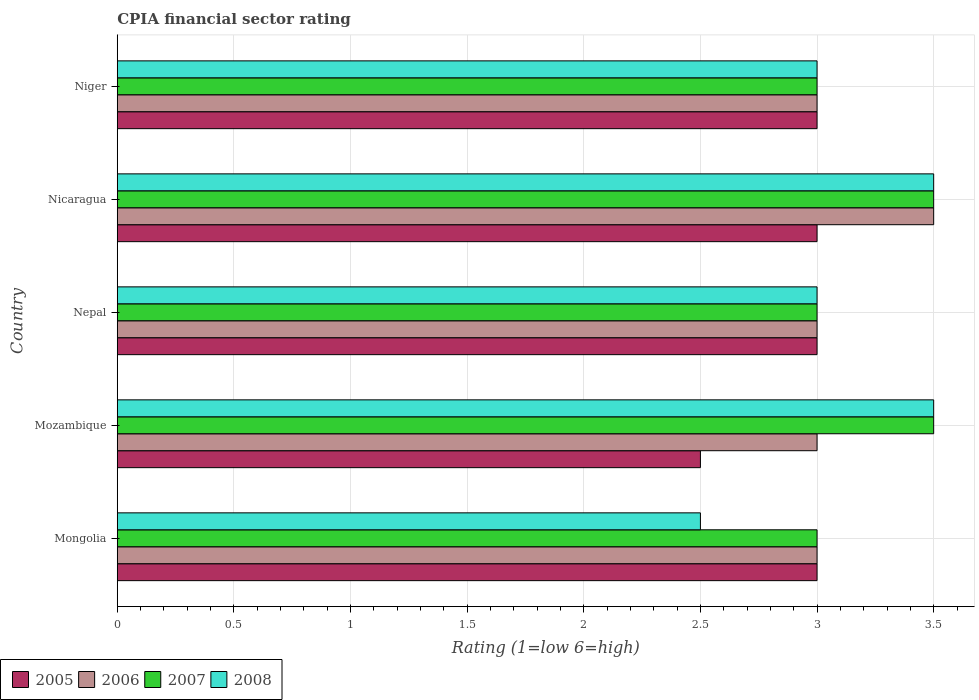How many groups of bars are there?
Make the answer very short. 5. Are the number of bars on each tick of the Y-axis equal?
Keep it short and to the point. Yes. How many bars are there on the 2nd tick from the top?
Provide a short and direct response. 4. What is the label of the 2nd group of bars from the top?
Ensure brevity in your answer.  Nicaragua. Across all countries, what is the minimum CPIA rating in 2008?
Your answer should be compact. 2.5. In which country was the CPIA rating in 2008 maximum?
Your answer should be compact. Mozambique. In which country was the CPIA rating in 2007 minimum?
Make the answer very short. Mongolia. What is the total CPIA rating in 2006 in the graph?
Offer a very short reply. 15.5. What is the difference between the CPIA rating in 2008 in Mongolia and that in Niger?
Provide a succinct answer. -0.5. What is the difference between the CPIA rating in 2006 in Niger and the CPIA rating in 2005 in Mongolia?
Your answer should be compact. 0. What is the ratio of the CPIA rating in 2005 in Nepal to that in Niger?
Your answer should be compact. 1. Is the CPIA rating in 2007 in Mongolia less than that in Niger?
Make the answer very short. No. Is it the case that in every country, the sum of the CPIA rating in 2005 and CPIA rating in 2006 is greater than the sum of CPIA rating in 2007 and CPIA rating in 2008?
Make the answer very short. No. What does the 1st bar from the top in Niger represents?
Your response must be concise. 2008. How many bars are there?
Make the answer very short. 20. Are all the bars in the graph horizontal?
Your answer should be very brief. Yes. How many countries are there in the graph?
Make the answer very short. 5. Does the graph contain grids?
Make the answer very short. Yes. How many legend labels are there?
Make the answer very short. 4. What is the title of the graph?
Your answer should be very brief. CPIA financial sector rating. What is the label or title of the X-axis?
Provide a succinct answer. Rating (1=low 6=high). What is the Rating (1=low 6=high) in 2005 in Mongolia?
Ensure brevity in your answer.  3. What is the Rating (1=low 6=high) in 2006 in Mongolia?
Your answer should be compact. 3. What is the Rating (1=low 6=high) in 2007 in Mongolia?
Provide a short and direct response. 3. What is the Rating (1=low 6=high) in 2005 in Mozambique?
Your response must be concise. 2.5. What is the Rating (1=low 6=high) of 2006 in Mozambique?
Your response must be concise. 3. What is the Rating (1=low 6=high) of 2008 in Mozambique?
Provide a succinct answer. 3.5. What is the Rating (1=low 6=high) of 2005 in Nicaragua?
Offer a terse response. 3. What is the Rating (1=low 6=high) in 2006 in Nicaragua?
Provide a short and direct response. 3.5. What is the Rating (1=low 6=high) in 2007 in Nicaragua?
Your answer should be very brief. 3.5. What is the Rating (1=low 6=high) in 2008 in Nicaragua?
Your response must be concise. 3.5. What is the Rating (1=low 6=high) in 2005 in Niger?
Keep it short and to the point. 3. What is the Rating (1=low 6=high) of 2006 in Niger?
Ensure brevity in your answer.  3. What is the Rating (1=low 6=high) in 2007 in Niger?
Give a very brief answer. 3. Across all countries, what is the maximum Rating (1=low 6=high) in 2006?
Offer a very short reply. 3.5. Across all countries, what is the maximum Rating (1=low 6=high) of 2008?
Your response must be concise. 3.5. Across all countries, what is the minimum Rating (1=low 6=high) in 2005?
Provide a succinct answer. 2.5. Across all countries, what is the minimum Rating (1=low 6=high) of 2006?
Your response must be concise. 3. What is the total Rating (1=low 6=high) of 2006 in the graph?
Offer a very short reply. 15.5. What is the total Rating (1=low 6=high) of 2008 in the graph?
Ensure brevity in your answer.  15.5. What is the difference between the Rating (1=low 6=high) of 2007 in Mongolia and that in Mozambique?
Provide a succinct answer. -0.5. What is the difference between the Rating (1=low 6=high) in 2008 in Mongolia and that in Mozambique?
Provide a succinct answer. -1. What is the difference between the Rating (1=low 6=high) in 2005 in Mongolia and that in Nepal?
Your answer should be very brief. 0. What is the difference between the Rating (1=low 6=high) of 2007 in Mongolia and that in Nepal?
Make the answer very short. 0. What is the difference between the Rating (1=low 6=high) of 2008 in Mongolia and that in Nepal?
Provide a short and direct response. -0.5. What is the difference between the Rating (1=low 6=high) of 2005 in Mongolia and that in Niger?
Your response must be concise. 0. What is the difference between the Rating (1=low 6=high) of 2007 in Mongolia and that in Niger?
Your response must be concise. 0. What is the difference between the Rating (1=low 6=high) of 2005 in Mozambique and that in Nepal?
Give a very brief answer. -0.5. What is the difference between the Rating (1=low 6=high) in 2006 in Mozambique and that in Nicaragua?
Offer a very short reply. -0.5. What is the difference between the Rating (1=low 6=high) of 2008 in Mozambique and that in Nicaragua?
Ensure brevity in your answer.  0. What is the difference between the Rating (1=low 6=high) in 2005 in Mozambique and that in Niger?
Your response must be concise. -0.5. What is the difference between the Rating (1=low 6=high) in 2007 in Mozambique and that in Niger?
Provide a short and direct response. 0.5. What is the difference between the Rating (1=low 6=high) in 2005 in Nepal and that in Nicaragua?
Make the answer very short. 0. What is the difference between the Rating (1=low 6=high) in 2006 in Nepal and that in Nicaragua?
Make the answer very short. -0.5. What is the difference between the Rating (1=low 6=high) of 2007 in Nepal and that in Nicaragua?
Offer a terse response. -0.5. What is the difference between the Rating (1=low 6=high) in 2008 in Nepal and that in Nicaragua?
Offer a very short reply. -0.5. What is the difference between the Rating (1=low 6=high) in 2005 in Nepal and that in Niger?
Give a very brief answer. 0. What is the difference between the Rating (1=low 6=high) in 2007 in Nepal and that in Niger?
Offer a terse response. 0. What is the difference between the Rating (1=low 6=high) of 2005 in Nicaragua and that in Niger?
Make the answer very short. 0. What is the difference between the Rating (1=low 6=high) in 2006 in Nicaragua and that in Niger?
Provide a succinct answer. 0.5. What is the difference between the Rating (1=low 6=high) of 2008 in Nicaragua and that in Niger?
Your answer should be very brief. 0.5. What is the difference between the Rating (1=low 6=high) in 2005 in Mongolia and the Rating (1=low 6=high) in 2006 in Mozambique?
Give a very brief answer. 0. What is the difference between the Rating (1=low 6=high) in 2006 in Mongolia and the Rating (1=low 6=high) in 2008 in Mozambique?
Provide a succinct answer. -0.5. What is the difference between the Rating (1=low 6=high) of 2005 in Mongolia and the Rating (1=low 6=high) of 2007 in Nepal?
Ensure brevity in your answer.  0. What is the difference between the Rating (1=low 6=high) in 2006 in Mongolia and the Rating (1=low 6=high) in 2008 in Nepal?
Give a very brief answer. 0. What is the difference between the Rating (1=low 6=high) of 2005 in Mongolia and the Rating (1=low 6=high) of 2006 in Nicaragua?
Your answer should be compact. -0.5. What is the difference between the Rating (1=low 6=high) of 2006 in Mongolia and the Rating (1=low 6=high) of 2007 in Nicaragua?
Keep it short and to the point. -0.5. What is the difference between the Rating (1=low 6=high) in 2005 in Mozambique and the Rating (1=low 6=high) in 2006 in Nepal?
Give a very brief answer. -0.5. What is the difference between the Rating (1=low 6=high) in 2005 in Mozambique and the Rating (1=low 6=high) in 2008 in Nepal?
Give a very brief answer. -0.5. What is the difference between the Rating (1=low 6=high) of 2006 in Mozambique and the Rating (1=low 6=high) of 2008 in Nepal?
Offer a very short reply. 0. What is the difference between the Rating (1=low 6=high) of 2007 in Mozambique and the Rating (1=low 6=high) of 2008 in Nepal?
Keep it short and to the point. 0.5. What is the difference between the Rating (1=low 6=high) of 2005 in Mozambique and the Rating (1=low 6=high) of 2006 in Nicaragua?
Provide a succinct answer. -1. What is the difference between the Rating (1=low 6=high) of 2005 in Mozambique and the Rating (1=low 6=high) of 2007 in Nicaragua?
Offer a very short reply. -1. What is the difference between the Rating (1=low 6=high) of 2006 in Mozambique and the Rating (1=low 6=high) of 2007 in Nicaragua?
Your answer should be very brief. -0.5. What is the difference between the Rating (1=low 6=high) of 2007 in Mozambique and the Rating (1=low 6=high) of 2008 in Nicaragua?
Ensure brevity in your answer.  0. What is the difference between the Rating (1=low 6=high) of 2005 in Mozambique and the Rating (1=low 6=high) of 2006 in Niger?
Make the answer very short. -0.5. What is the difference between the Rating (1=low 6=high) in 2005 in Mozambique and the Rating (1=low 6=high) in 2007 in Niger?
Your response must be concise. -0.5. What is the difference between the Rating (1=low 6=high) of 2005 in Nepal and the Rating (1=low 6=high) of 2006 in Nicaragua?
Offer a very short reply. -0.5. What is the difference between the Rating (1=low 6=high) of 2005 in Nepal and the Rating (1=low 6=high) of 2007 in Nicaragua?
Provide a short and direct response. -0.5. What is the difference between the Rating (1=low 6=high) in 2007 in Nepal and the Rating (1=low 6=high) in 2008 in Nicaragua?
Offer a terse response. -0.5. What is the difference between the Rating (1=low 6=high) of 2005 in Nepal and the Rating (1=low 6=high) of 2006 in Niger?
Ensure brevity in your answer.  0. What is the difference between the Rating (1=low 6=high) of 2005 in Nepal and the Rating (1=low 6=high) of 2007 in Niger?
Provide a short and direct response. 0. What is the difference between the Rating (1=low 6=high) in 2006 in Nepal and the Rating (1=low 6=high) in 2007 in Niger?
Make the answer very short. 0. What is the difference between the Rating (1=low 6=high) in 2006 in Nepal and the Rating (1=low 6=high) in 2008 in Niger?
Your answer should be very brief. 0. What is the difference between the Rating (1=low 6=high) of 2007 in Nepal and the Rating (1=low 6=high) of 2008 in Niger?
Ensure brevity in your answer.  0. What is the difference between the Rating (1=low 6=high) of 2005 in Nicaragua and the Rating (1=low 6=high) of 2006 in Niger?
Provide a short and direct response. 0. What is the difference between the Rating (1=low 6=high) in 2005 in Nicaragua and the Rating (1=low 6=high) in 2007 in Niger?
Make the answer very short. 0. What is the difference between the Rating (1=low 6=high) of 2006 in Nicaragua and the Rating (1=low 6=high) of 2007 in Niger?
Give a very brief answer. 0.5. What is the average Rating (1=low 6=high) of 2005 per country?
Provide a succinct answer. 2.9. What is the average Rating (1=low 6=high) of 2006 per country?
Your answer should be compact. 3.1. What is the average Rating (1=low 6=high) in 2007 per country?
Your answer should be very brief. 3.2. What is the average Rating (1=low 6=high) of 2008 per country?
Your answer should be very brief. 3.1. What is the difference between the Rating (1=low 6=high) of 2006 and Rating (1=low 6=high) of 2007 in Mongolia?
Give a very brief answer. 0. What is the difference between the Rating (1=low 6=high) of 2007 and Rating (1=low 6=high) of 2008 in Mongolia?
Provide a succinct answer. 0.5. What is the difference between the Rating (1=low 6=high) of 2005 and Rating (1=low 6=high) of 2006 in Mozambique?
Make the answer very short. -0.5. What is the difference between the Rating (1=low 6=high) in 2005 and Rating (1=low 6=high) in 2007 in Mozambique?
Make the answer very short. -1. What is the difference between the Rating (1=low 6=high) of 2005 and Rating (1=low 6=high) of 2008 in Mozambique?
Provide a short and direct response. -1. What is the difference between the Rating (1=low 6=high) in 2006 and Rating (1=low 6=high) in 2008 in Mozambique?
Provide a short and direct response. -0.5. What is the difference between the Rating (1=low 6=high) in 2007 and Rating (1=low 6=high) in 2008 in Mozambique?
Offer a very short reply. 0. What is the difference between the Rating (1=low 6=high) of 2005 and Rating (1=low 6=high) of 2006 in Nepal?
Offer a terse response. 0. What is the difference between the Rating (1=low 6=high) in 2005 and Rating (1=low 6=high) in 2007 in Nepal?
Your answer should be very brief. 0. What is the difference between the Rating (1=low 6=high) of 2005 and Rating (1=low 6=high) of 2008 in Nepal?
Keep it short and to the point. 0. What is the difference between the Rating (1=low 6=high) of 2006 and Rating (1=low 6=high) of 2007 in Nepal?
Make the answer very short. 0. What is the difference between the Rating (1=low 6=high) in 2005 and Rating (1=low 6=high) in 2006 in Nicaragua?
Provide a succinct answer. -0.5. What is the difference between the Rating (1=low 6=high) in 2005 and Rating (1=low 6=high) in 2007 in Nicaragua?
Make the answer very short. -0.5. What is the difference between the Rating (1=low 6=high) in 2006 and Rating (1=low 6=high) in 2007 in Nicaragua?
Your answer should be compact. 0. What is the difference between the Rating (1=low 6=high) in 2007 and Rating (1=low 6=high) in 2008 in Nicaragua?
Keep it short and to the point. 0. What is the difference between the Rating (1=low 6=high) in 2005 and Rating (1=low 6=high) in 2007 in Niger?
Provide a succinct answer. 0. What is the difference between the Rating (1=low 6=high) of 2006 and Rating (1=low 6=high) of 2008 in Niger?
Your response must be concise. 0. What is the ratio of the Rating (1=low 6=high) in 2007 in Mongolia to that in Mozambique?
Keep it short and to the point. 0.86. What is the ratio of the Rating (1=low 6=high) of 2006 in Mongolia to that in Nepal?
Your answer should be compact. 1. What is the ratio of the Rating (1=low 6=high) in 2005 in Mongolia to that in Nicaragua?
Provide a succinct answer. 1. What is the ratio of the Rating (1=low 6=high) in 2006 in Mongolia to that in Nicaragua?
Give a very brief answer. 0.86. What is the ratio of the Rating (1=low 6=high) in 2007 in Mongolia to that in Nicaragua?
Offer a very short reply. 0.86. What is the ratio of the Rating (1=low 6=high) of 2005 in Mongolia to that in Niger?
Your answer should be very brief. 1. What is the ratio of the Rating (1=low 6=high) of 2006 in Mongolia to that in Niger?
Make the answer very short. 1. What is the ratio of the Rating (1=low 6=high) in 2007 in Mongolia to that in Niger?
Provide a short and direct response. 1. What is the ratio of the Rating (1=low 6=high) of 2008 in Mongolia to that in Niger?
Offer a very short reply. 0.83. What is the ratio of the Rating (1=low 6=high) in 2005 in Mozambique to that in Nepal?
Ensure brevity in your answer.  0.83. What is the ratio of the Rating (1=low 6=high) in 2006 in Mozambique to that in Nepal?
Provide a short and direct response. 1. What is the ratio of the Rating (1=low 6=high) of 2007 in Mozambique to that in Nepal?
Make the answer very short. 1.17. What is the ratio of the Rating (1=low 6=high) in 2008 in Mozambique to that in Nepal?
Your answer should be very brief. 1.17. What is the ratio of the Rating (1=low 6=high) of 2005 in Mozambique to that in Nicaragua?
Give a very brief answer. 0.83. What is the ratio of the Rating (1=low 6=high) in 2006 in Mozambique to that in Nicaragua?
Make the answer very short. 0.86. What is the ratio of the Rating (1=low 6=high) of 2006 in Mozambique to that in Niger?
Your answer should be compact. 1. What is the ratio of the Rating (1=low 6=high) in 2007 in Mozambique to that in Niger?
Provide a succinct answer. 1.17. What is the ratio of the Rating (1=low 6=high) in 2005 in Nepal to that in Nicaragua?
Provide a short and direct response. 1. What is the ratio of the Rating (1=low 6=high) of 2006 in Nepal to that in Nicaragua?
Your answer should be compact. 0.86. What is the ratio of the Rating (1=low 6=high) of 2007 in Nepal to that in Nicaragua?
Provide a short and direct response. 0.86. What is the ratio of the Rating (1=low 6=high) in 2005 in Nepal to that in Niger?
Your answer should be compact. 1. What is the ratio of the Rating (1=low 6=high) in 2006 in Nepal to that in Niger?
Offer a very short reply. 1. What is the ratio of the Rating (1=low 6=high) in 2008 in Nepal to that in Niger?
Make the answer very short. 1. What is the ratio of the Rating (1=low 6=high) in 2006 in Nicaragua to that in Niger?
Ensure brevity in your answer.  1.17. What is the difference between the highest and the second highest Rating (1=low 6=high) in 2005?
Give a very brief answer. 0. What is the difference between the highest and the second highest Rating (1=low 6=high) of 2006?
Give a very brief answer. 0.5. What is the difference between the highest and the lowest Rating (1=low 6=high) of 2006?
Your response must be concise. 0.5. 